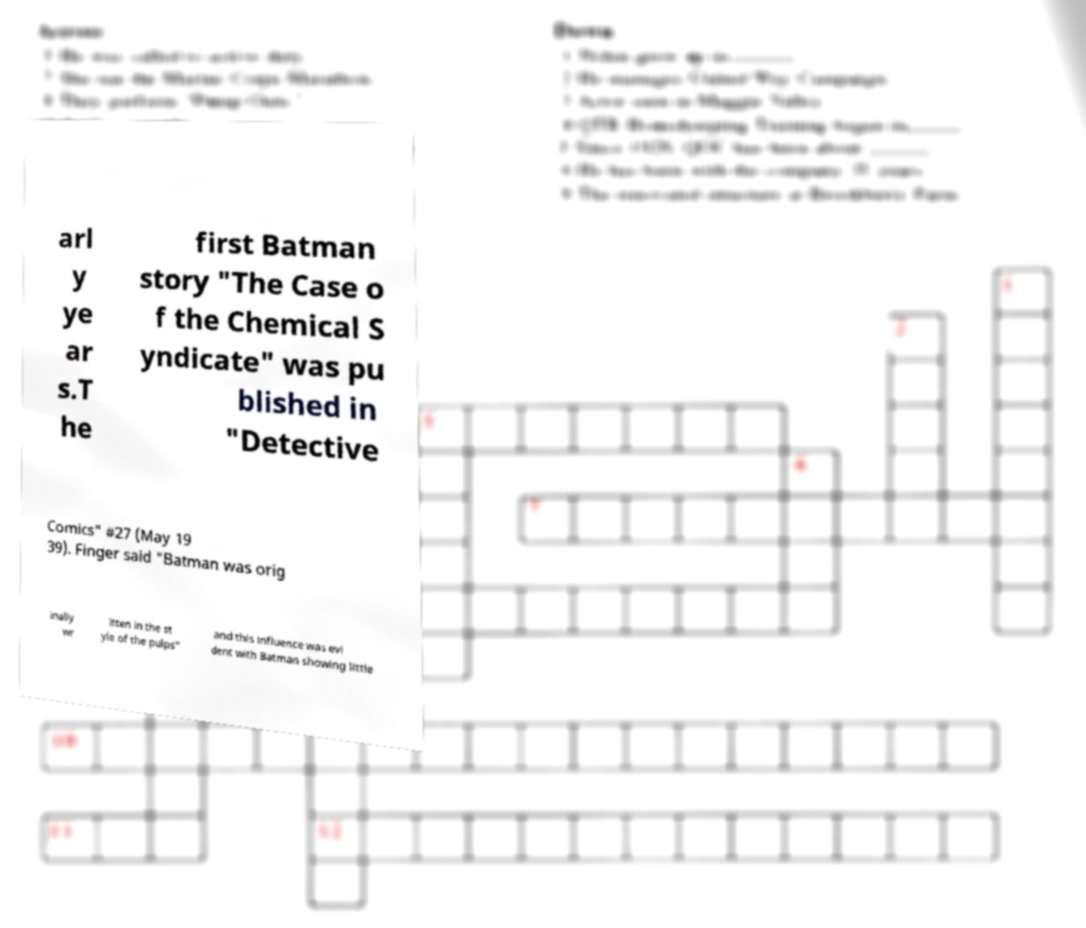What messages or text are displayed in this image? I need them in a readable, typed format. arl y ye ar s.T he first Batman story "The Case o f the Chemical S yndicate" was pu blished in "Detective Comics" #27 (May 19 39). Finger said "Batman was orig inally wr itten in the st yle of the pulps" and this influence was evi dent with Batman showing little 